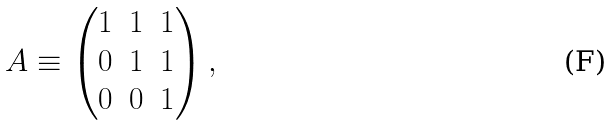Convert formula to latex. <formula><loc_0><loc_0><loc_500><loc_500>A \equiv \begin{pmatrix} 1 & 1 & 1 \\ 0 & 1 & 1 \\ 0 & 0 & 1 \end{pmatrix} ,</formula> 